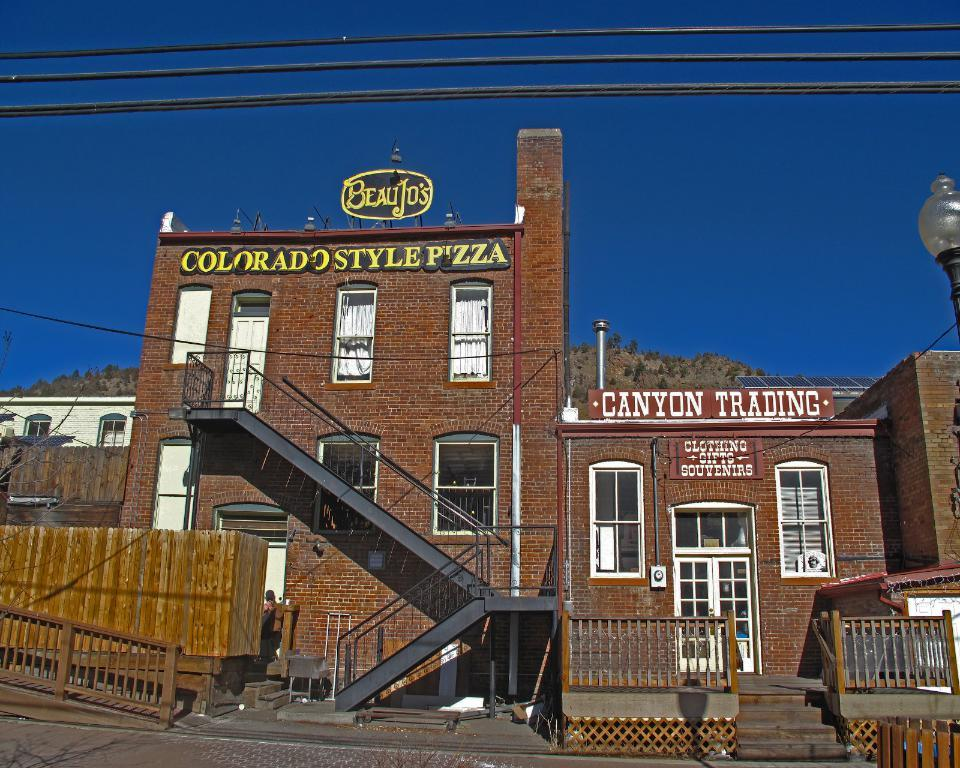What structures are located in the middle of the image? There are buildings in the middle of the image. What can be seen behind the buildings? There is a hill visible behind the buildings. What is visible in the image besides the buildings and hill? The sky is visible in the image. What type of need can be seen growing on the hill in the image? There is no mention of any specific plant or object called "need" in the image, and therefore it cannot be determined if any such item is present. 